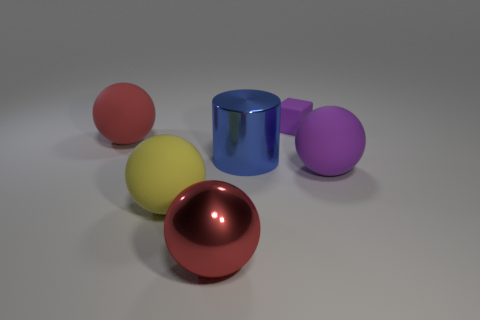What number of purple things are tiny matte things or tiny cylinders? In the image, among the purple objects, there appears to be one that could be classified as tiny and cylindrical - it's the small purple sphere-like object. While a precise definition of 'cylinder' might vary, this object has a circular base and could be considered as a short, stout cylinder. The matte quality isn’t as clearly defined visually without an understanding of the material properties, but none of the objects exhibit a high level of sheen that would suggest they are not matte. Hence, based on a broad interpretation, we can say there is 1 purple object that falls under the category of a 'tiny cylinder' or 'tiny matte thing'. 